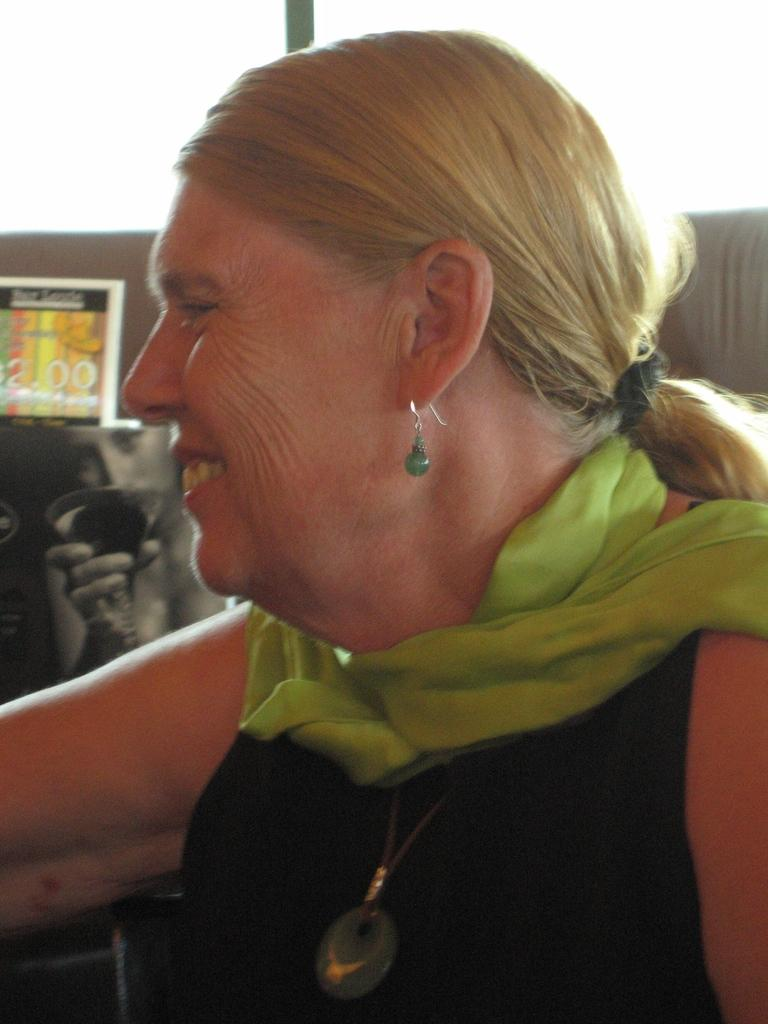Who is the main subject in the image? There is a woman in the image. What is the woman wearing around her neck? The woman is wearing a green stole. What color is the dress the woman is wearing? The woman is wearing a black dress. What type of accessory is the woman wearing in her ear? The woman is wearing an earring. What is the color of the woman's hair? The woman has blonde hair. How does the woman taste the bomb in the image? There is no bomb present in the image, and therefore the woman cannot taste it. 